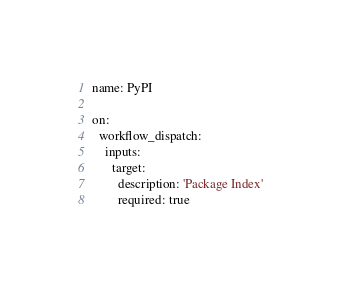Convert code to text. <code><loc_0><loc_0><loc_500><loc_500><_YAML_>name: PyPI

on:
  workflow_dispatch:
    inputs:
      target:
        description: 'Package Index'
        required: true</code> 